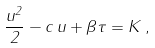<formula> <loc_0><loc_0><loc_500><loc_500>\frac { u ^ { 2 } } { 2 } - c \, u + \beta \tau = K \, ,</formula> 